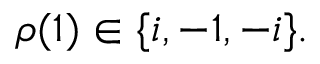<formula> <loc_0><loc_0><loc_500><loc_500>\rho ( { 1 } ) \in \{ i , - 1 , - i \} .</formula> 